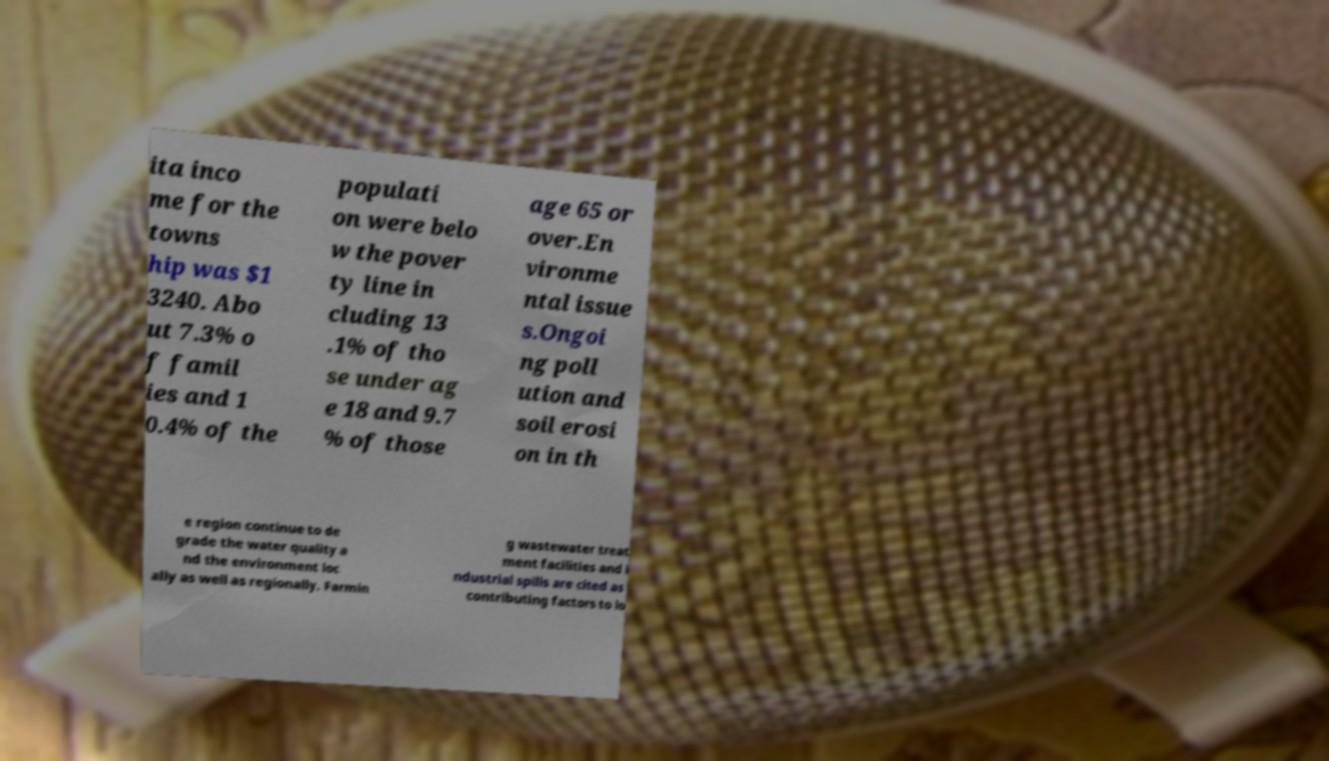For documentation purposes, I need the text within this image transcribed. Could you provide that? ita inco me for the towns hip was $1 3240. Abo ut 7.3% o f famil ies and 1 0.4% of the populati on were belo w the pover ty line in cluding 13 .1% of tho se under ag e 18 and 9.7 % of those age 65 or over.En vironme ntal issue s.Ongoi ng poll ution and soil erosi on in th e region continue to de grade the water quality a nd the environment loc ally as well as regionally. Farmin g wastewater treat ment facilities and i ndustrial spills are cited as contributing factors to lo 